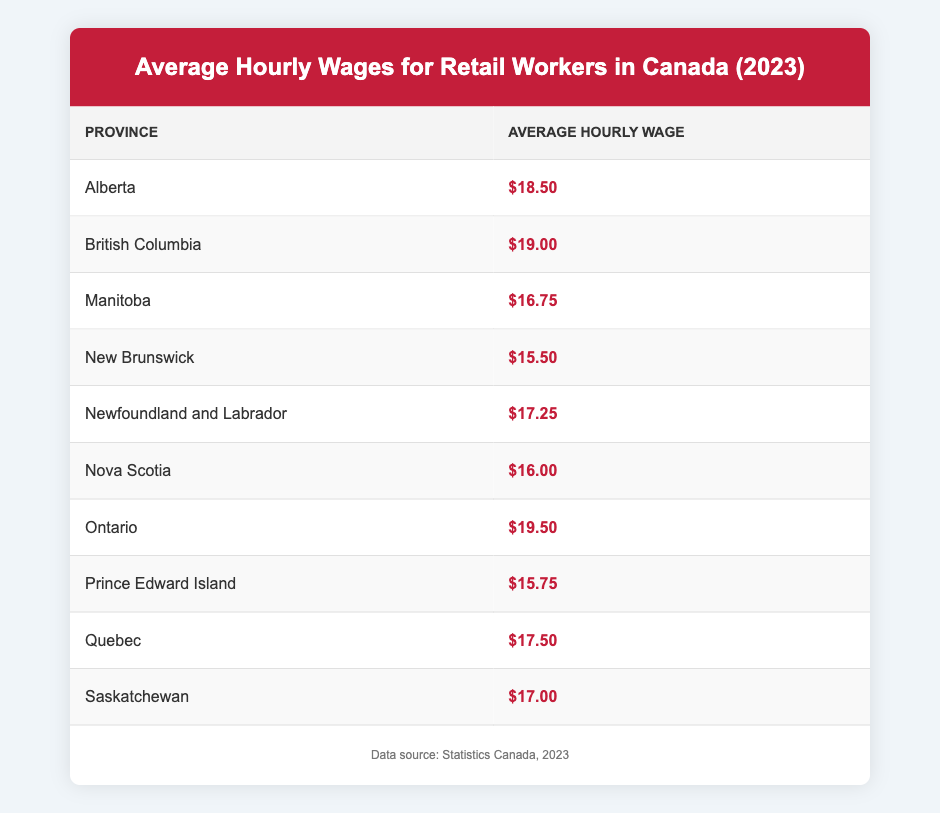What is the average hourly wage for retail workers in Ontario? Ontario's average hourly wage for retail workers is listed directly in the table as $19.50.
Answer: $19.50 Which province has the lowest average hourly wage for retail workers? By scanning the table, New Brunswick has the lowest wage of $15.50 among the listed provinces.
Answer: New Brunswick What is the difference in average hourly wages between British Columbia and Manitoba? The average hourly wage for British Columbia is $19.00, while Manitoba's is $16.75. The difference is calculated as $19.00 - $16.75 = $2.25.
Answer: $2.25 Is the average hourly wage for retail workers higher in Alberta compared to Quebec? Alberta's average is $18.50, while Quebec's is $17.50. Since $18.50 is greater than $17.50, the statement is true.
Answer: Yes What is the average hourly wage of retail workers across all provinces? To find the average, sum the wages: (18.50 + 19.00 + 16.75 + 15.50 + 17.25 + 16.00 + 19.50 + 15.75 + 17.50 + 17.00) =  18.50 + 19.00 + 16.75 + 15.50 + 17.25 + 16.00 + 19.50 + 15.75 + 17.50 + 17.00 =  18.25. Divide by the number of provinces (10): 182.5 / 10 = 18.25.
Answer: $18.25 Is it true that the average hourly wage in Nova Scotia is greater than $17.00? Nova Scotia's average wage is listed as $16.00, which is less than $17.00. Therefore, the statement is false.
Answer: No 